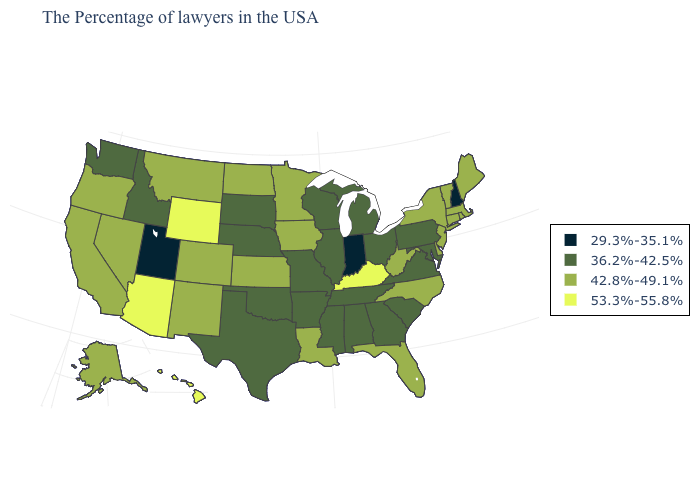Name the states that have a value in the range 29.3%-35.1%?
Write a very short answer. New Hampshire, Indiana, Utah. What is the value of Idaho?
Answer briefly. 36.2%-42.5%. Which states hav the highest value in the South?
Write a very short answer. Kentucky. Does the first symbol in the legend represent the smallest category?
Quick response, please. Yes. Does Wisconsin have a higher value than Florida?
Keep it brief. No. Does the map have missing data?
Give a very brief answer. No. Does the first symbol in the legend represent the smallest category?
Be succinct. Yes. Does the map have missing data?
Short answer required. No. Which states hav the highest value in the Northeast?
Keep it brief. Maine, Massachusetts, Rhode Island, Vermont, Connecticut, New York, New Jersey. Does the first symbol in the legend represent the smallest category?
Concise answer only. Yes. Does Alaska have a lower value than Texas?
Give a very brief answer. No. What is the lowest value in the West?
Short answer required. 29.3%-35.1%. What is the highest value in the USA?
Give a very brief answer. 53.3%-55.8%. Name the states that have a value in the range 53.3%-55.8%?
Answer briefly. Kentucky, Wyoming, Arizona, Hawaii. 